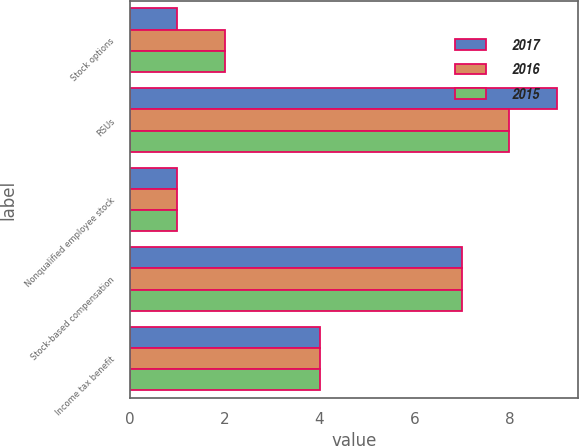Convert chart to OTSL. <chart><loc_0><loc_0><loc_500><loc_500><stacked_bar_chart><ecel><fcel>Stock options<fcel>RSUs<fcel>Nonqualified employee stock<fcel>Stock-based compensation<fcel>Income tax benefit<nl><fcel>2017<fcel>1<fcel>9<fcel>1<fcel>7<fcel>4<nl><fcel>2016<fcel>2<fcel>8<fcel>1<fcel>7<fcel>4<nl><fcel>2015<fcel>2<fcel>8<fcel>1<fcel>7<fcel>4<nl></chart> 